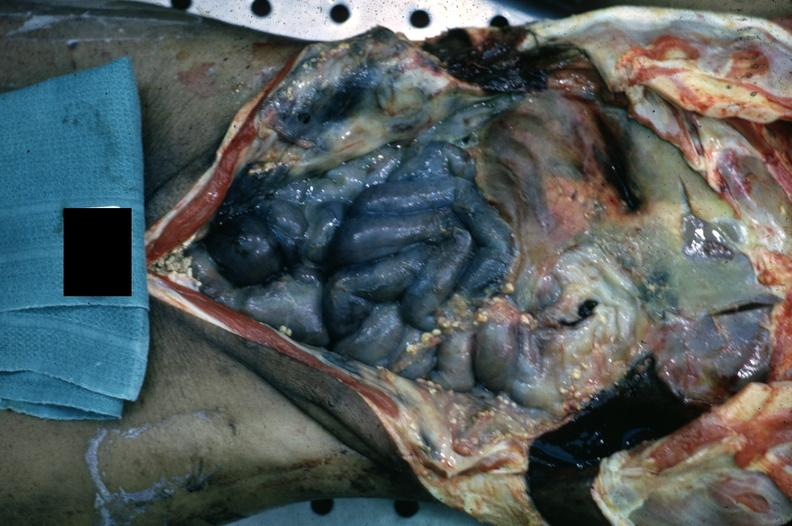what is present?
Answer the question using a single word or phrase. Abdomen 